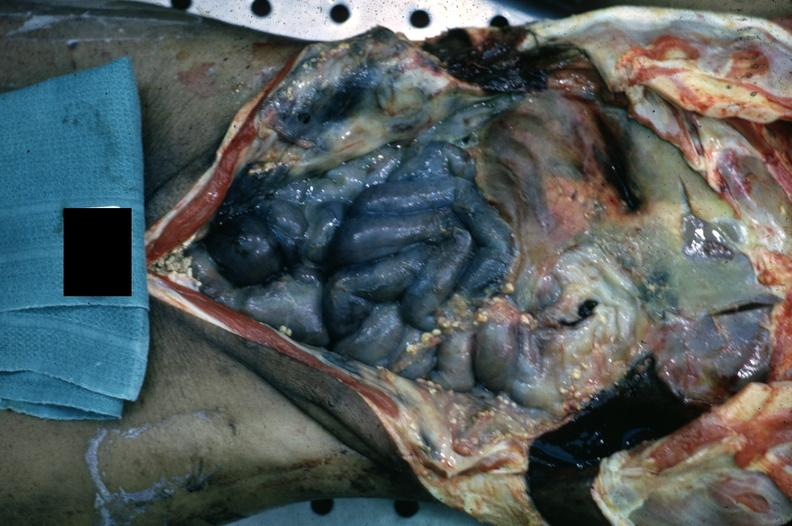what is present?
Answer the question using a single word or phrase. Abdomen 